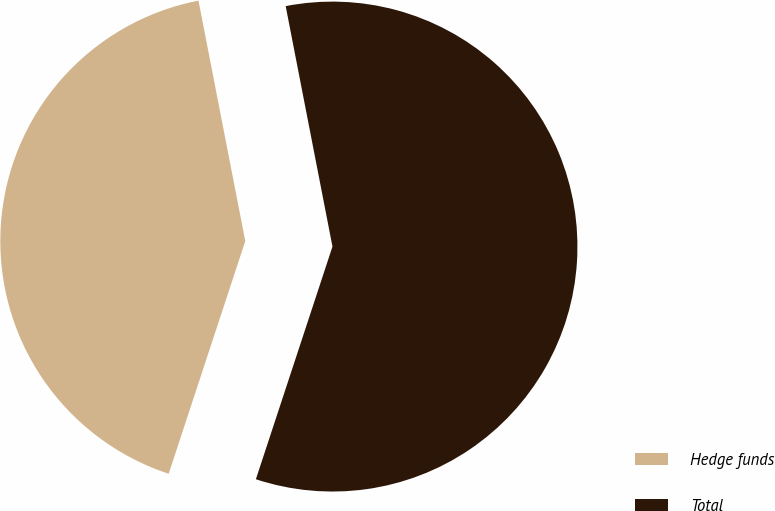<chart> <loc_0><loc_0><loc_500><loc_500><pie_chart><fcel>Hedge funds<fcel>Total<nl><fcel>41.88%<fcel>58.12%<nl></chart> 